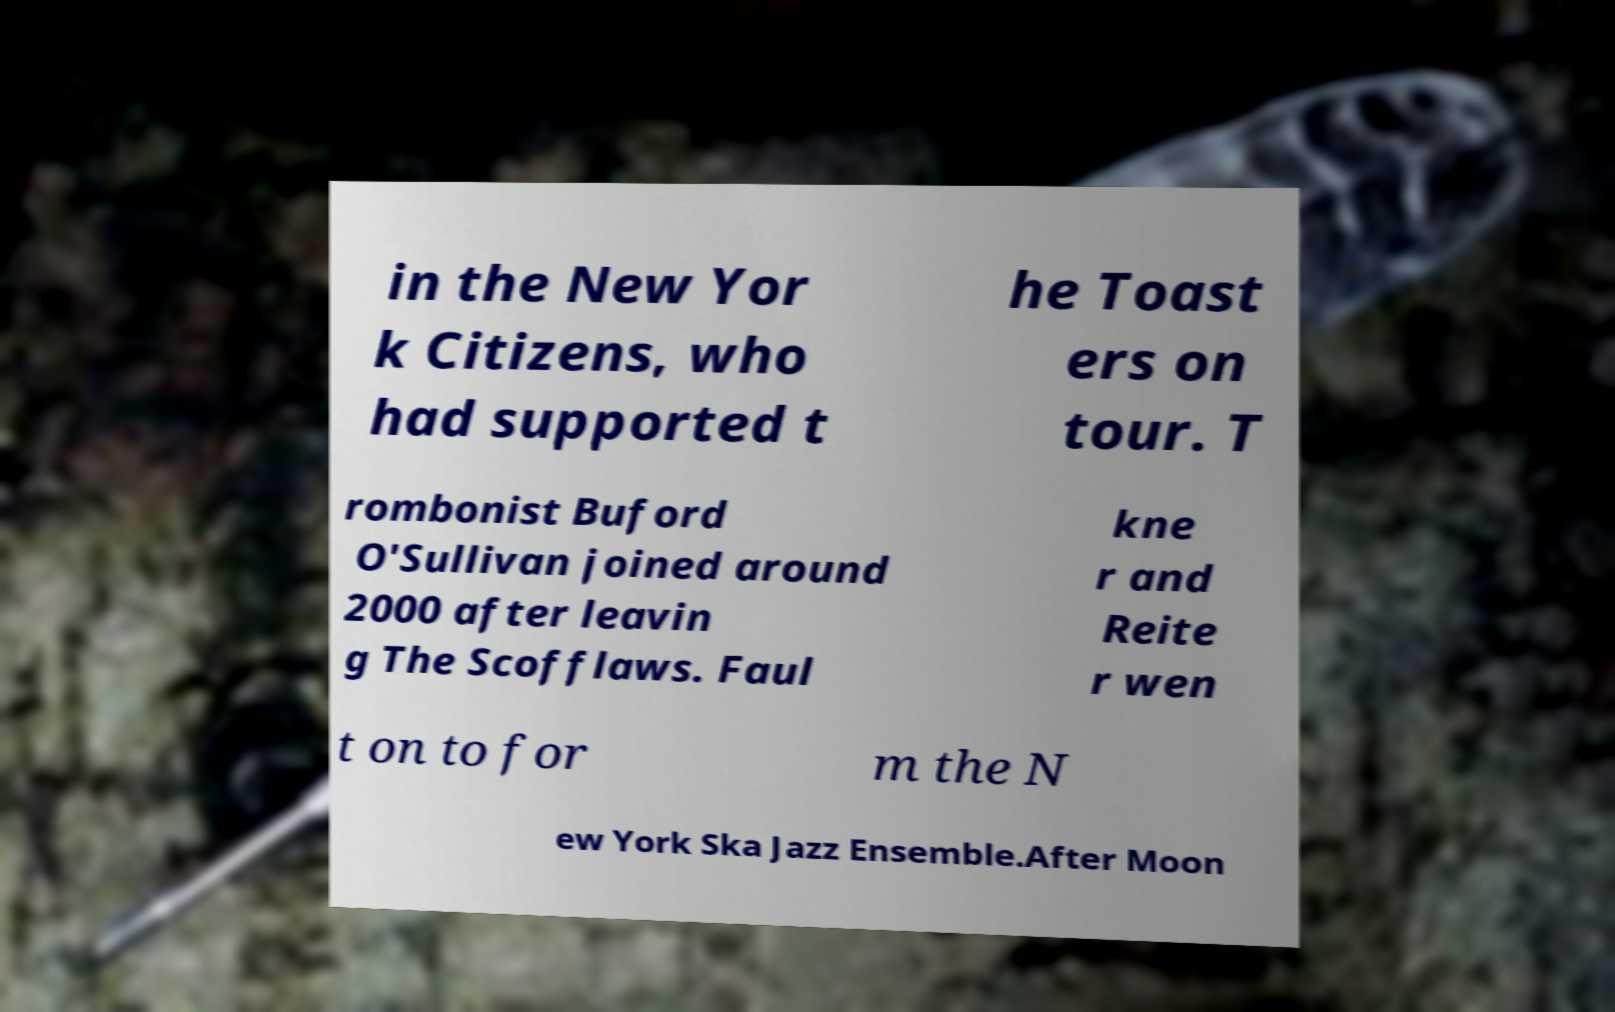For documentation purposes, I need the text within this image transcribed. Could you provide that? in the New Yor k Citizens, who had supported t he Toast ers on tour. T rombonist Buford O'Sullivan joined around 2000 after leavin g The Scofflaws. Faul kne r and Reite r wen t on to for m the N ew York Ska Jazz Ensemble.After Moon 